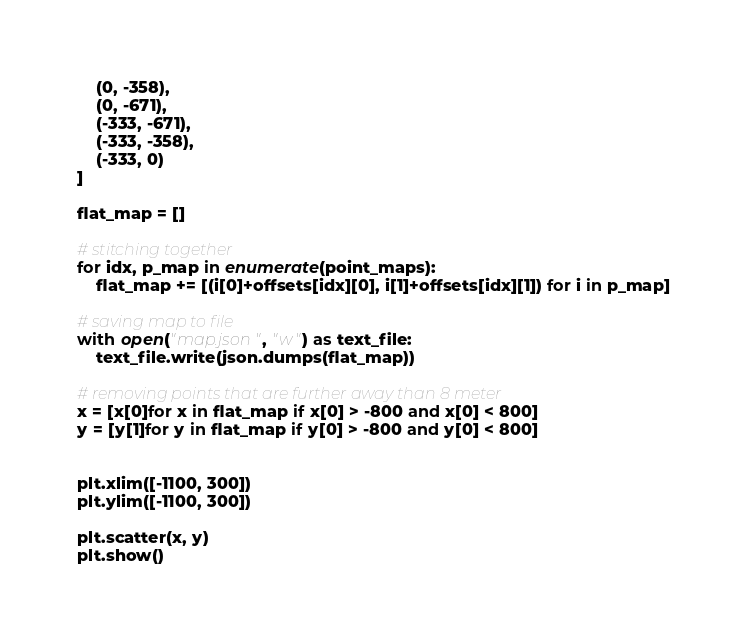<code> <loc_0><loc_0><loc_500><loc_500><_Python_>    (0, -358),
    (0, -671),
    (-333, -671),
    (-333, -358),
    (-333, 0)
]

flat_map = []

# stitching together
for idx, p_map in enumerate(point_maps):
    flat_map += [(i[0]+offsets[idx][0], i[1]+offsets[idx][1]) for i in p_map]

# saving map to file
with open("map.json", "w") as text_file:
    text_file.write(json.dumps(flat_map))

# removing points that are further away than 8 meter
x = [x[0]for x in flat_map if x[0] > -800 and x[0] < 800]
y = [y[1]for y in flat_map if y[0] > -800 and y[0] < 800]


plt.xlim([-1100, 300])
plt.ylim([-1100, 300])

plt.scatter(x, y)
plt.show()
</code> 